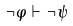<formula> <loc_0><loc_0><loc_500><loc_500>\neg \varphi \vdash \neg \psi</formula> 